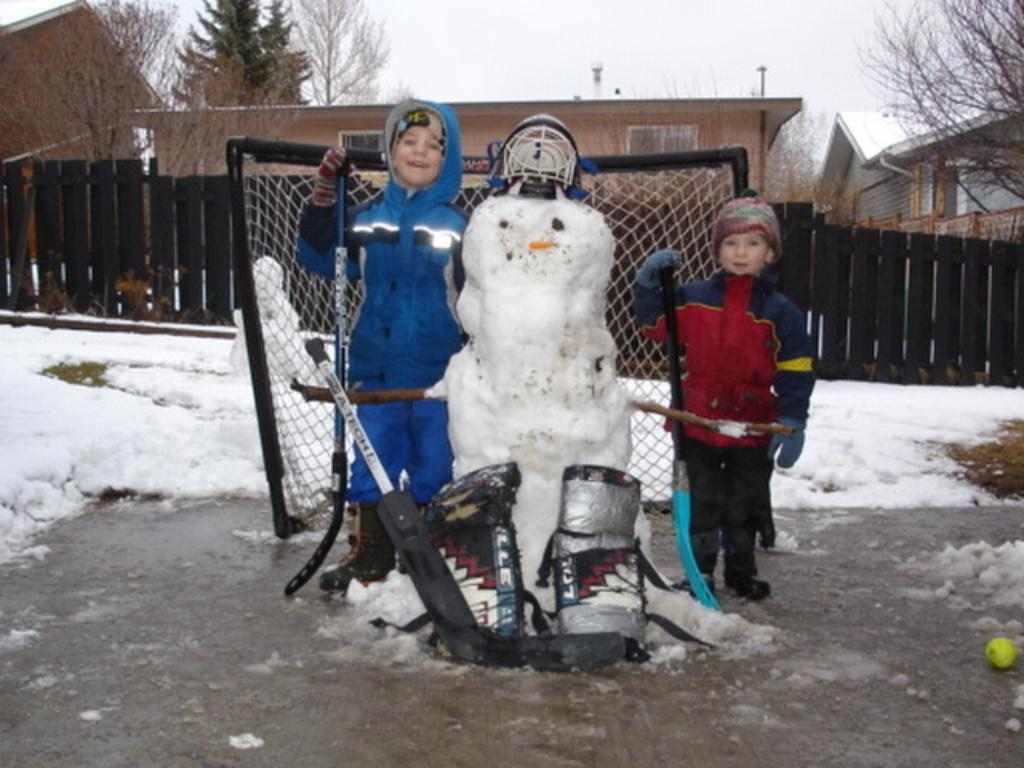How many children are in the image? There are two children in the image. What is the object made with snow in the image? The object made with snow is an object in the image. What is the object made of? The object is made of snow. Can you describe the mesh in the image? There is a mesh in the image, but no specific details are provided about its appearance or function. What can be seen in the background of the image? In the background of the image, there is a fence, houses, trees, and the sky. What type of ring can be seen on the children's fingers in the image? There are no rings visible on the children's fingers in the image. What is the children's desire in the image? The image does not provide any information about the children's desires or emotions. 